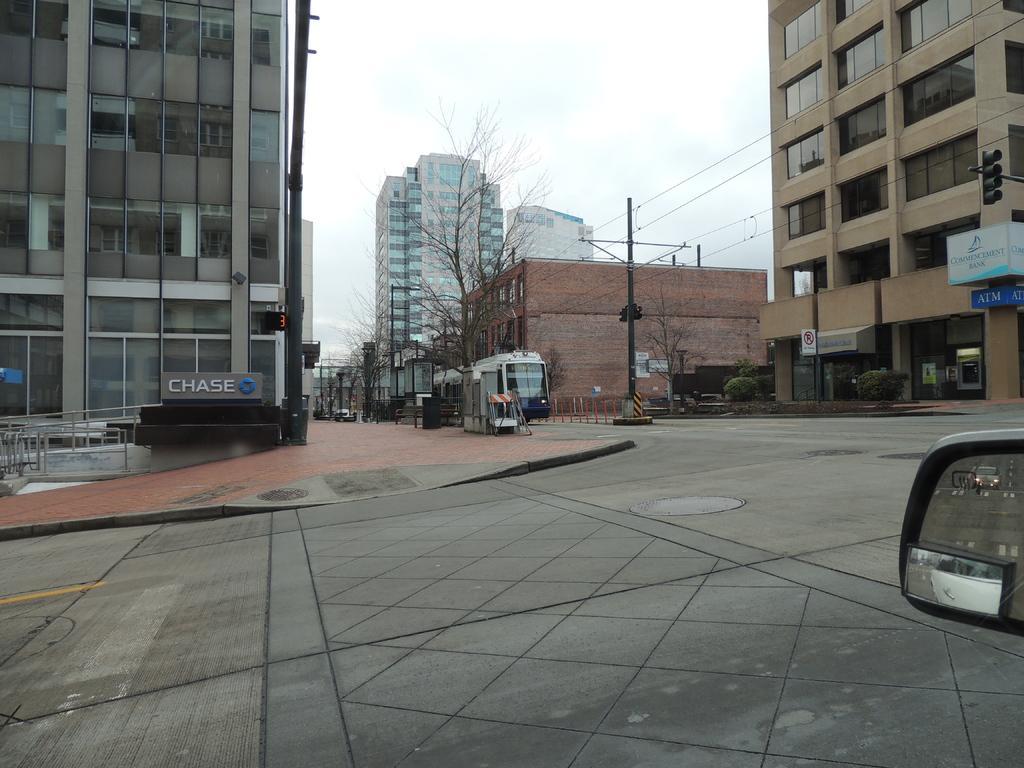How would you summarize this image in a sentence or two? In the image I can see a place where we have some buildings and also I can see some poles, lights, trees, plants and some vehicles. 